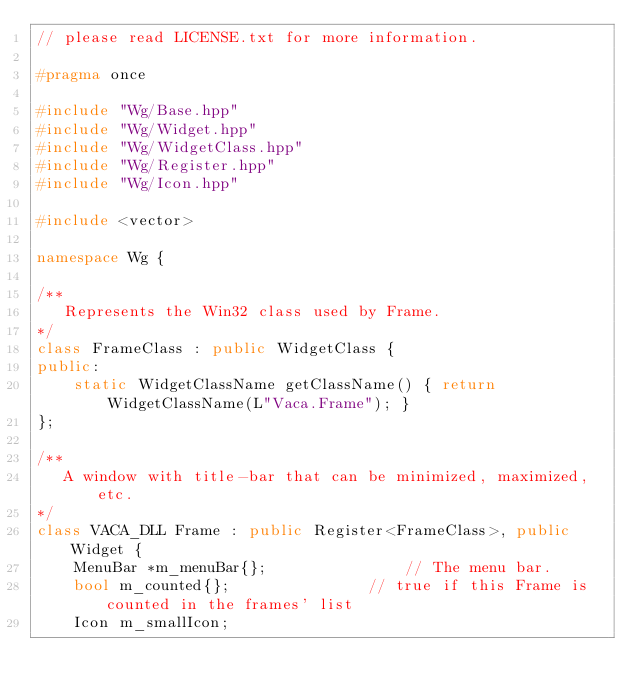<code> <loc_0><loc_0><loc_500><loc_500><_C++_>// please read LICENSE.txt for more information.

#pragma once

#include "Wg/Base.hpp"
#include "Wg/Widget.hpp"
#include "Wg/WidgetClass.hpp"
#include "Wg/Register.hpp"
#include "Wg/Icon.hpp"

#include <vector>

namespace Wg {

/**
   Represents the Win32 class used by Frame.
*/
class FrameClass : public WidgetClass {
public:
    static WidgetClassName getClassName() { return WidgetClassName(L"Vaca.Frame"); }
};

/**
   A window with title-bar that can be minimized, maximized, etc.
*/
class VACA_DLL Frame : public Register<FrameClass>, public Widget {
    MenuBar *m_menuBar{};               // The menu bar.
    bool m_counted{};               // true if this Frame is counted in the frames' list
    Icon m_smallIcon;</code> 